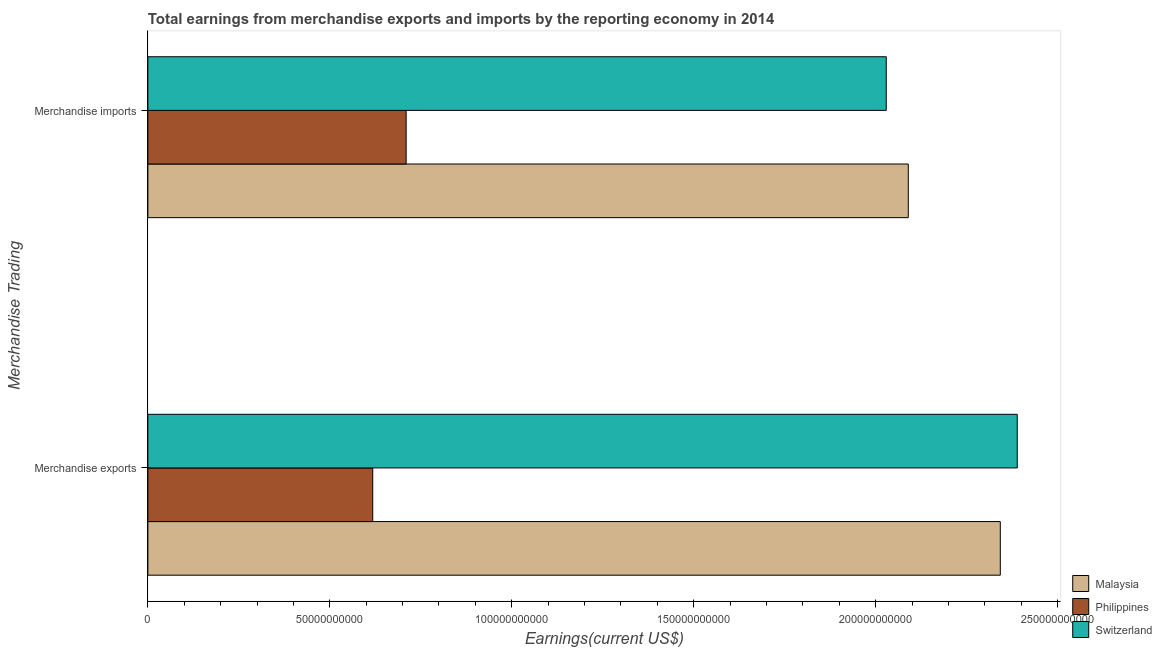How many different coloured bars are there?
Offer a very short reply. 3. Are the number of bars per tick equal to the number of legend labels?
Offer a very short reply. Yes. How many bars are there on the 2nd tick from the top?
Offer a terse response. 3. How many bars are there on the 1st tick from the bottom?
Your response must be concise. 3. What is the earnings from merchandise exports in Switzerland?
Make the answer very short. 2.39e+11. Across all countries, what is the maximum earnings from merchandise imports?
Your answer should be compact. 2.09e+11. Across all countries, what is the minimum earnings from merchandise imports?
Ensure brevity in your answer.  7.10e+1. In which country was the earnings from merchandise exports maximum?
Your answer should be very brief. Switzerland. In which country was the earnings from merchandise imports minimum?
Provide a succinct answer. Philippines. What is the total earnings from merchandise imports in the graph?
Your answer should be compact. 4.83e+11. What is the difference between the earnings from merchandise exports in Philippines and that in Switzerland?
Make the answer very short. -1.77e+11. What is the difference between the earnings from merchandise imports in Philippines and the earnings from merchandise exports in Malaysia?
Your answer should be compact. -1.63e+11. What is the average earnings from merchandise exports per country?
Offer a very short reply. 1.78e+11. What is the difference between the earnings from merchandise exports and earnings from merchandise imports in Switzerland?
Your answer should be very brief. 3.60e+1. What is the ratio of the earnings from merchandise exports in Malaysia to that in Philippines?
Ensure brevity in your answer.  3.79. In how many countries, is the earnings from merchandise imports greater than the average earnings from merchandise imports taken over all countries?
Offer a terse response. 2. What does the 3rd bar from the top in Merchandise exports represents?
Make the answer very short. Malaysia. What does the 1st bar from the bottom in Merchandise exports represents?
Offer a terse response. Malaysia. How many bars are there?
Offer a very short reply. 6. How many countries are there in the graph?
Offer a terse response. 3. Does the graph contain any zero values?
Offer a very short reply. No. Where does the legend appear in the graph?
Keep it short and to the point. Bottom right. How many legend labels are there?
Keep it short and to the point. 3. What is the title of the graph?
Offer a very short reply. Total earnings from merchandise exports and imports by the reporting economy in 2014. What is the label or title of the X-axis?
Make the answer very short. Earnings(current US$). What is the label or title of the Y-axis?
Ensure brevity in your answer.  Merchandise Trading. What is the Earnings(current US$) of Malaysia in Merchandise exports?
Provide a short and direct response. 2.34e+11. What is the Earnings(current US$) of Philippines in Merchandise exports?
Offer a very short reply. 6.18e+1. What is the Earnings(current US$) of Switzerland in Merchandise exports?
Your answer should be very brief. 2.39e+11. What is the Earnings(current US$) in Malaysia in Merchandise imports?
Give a very brief answer. 2.09e+11. What is the Earnings(current US$) in Philippines in Merchandise imports?
Your answer should be very brief. 7.10e+1. What is the Earnings(current US$) in Switzerland in Merchandise imports?
Give a very brief answer. 2.03e+11. Across all Merchandise Trading, what is the maximum Earnings(current US$) in Malaysia?
Provide a succinct answer. 2.34e+11. Across all Merchandise Trading, what is the maximum Earnings(current US$) in Philippines?
Your response must be concise. 7.10e+1. Across all Merchandise Trading, what is the maximum Earnings(current US$) of Switzerland?
Your answer should be very brief. 2.39e+11. Across all Merchandise Trading, what is the minimum Earnings(current US$) of Malaysia?
Your answer should be very brief. 2.09e+11. Across all Merchandise Trading, what is the minimum Earnings(current US$) of Philippines?
Keep it short and to the point. 6.18e+1. Across all Merchandise Trading, what is the minimum Earnings(current US$) in Switzerland?
Ensure brevity in your answer.  2.03e+11. What is the total Earnings(current US$) of Malaysia in the graph?
Your answer should be compact. 4.43e+11. What is the total Earnings(current US$) in Philippines in the graph?
Keep it short and to the point. 1.33e+11. What is the total Earnings(current US$) of Switzerland in the graph?
Your response must be concise. 4.42e+11. What is the difference between the Earnings(current US$) in Malaysia in Merchandise exports and that in Merchandise imports?
Your answer should be compact. 2.53e+1. What is the difference between the Earnings(current US$) of Philippines in Merchandise exports and that in Merchandise imports?
Ensure brevity in your answer.  -9.18e+09. What is the difference between the Earnings(current US$) in Switzerland in Merchandise exports and that in Merchandise imports?
Your answer should be very brief. 3.60e+1. What is the difference between the Earnings(current US$) of Malaysia in Merchandise exports and the Earnings(current US$) of Philippines in Merchandise imports?
Provide a short and direct response. 1.63e+11. What is the difference between the Earnings(current US$) in Malaysia in Merchandise exports and the Earnings(current US$) in Switzerland in Merchandise imports?
Your response must be concise. 3.13e+1. What is the difference between the Earnings(current US$) in Philippines in Merchandise exports and the Earnings(current US$) in Switzerland in Merchandise imports?
Offer a very short reply. -1.41e+11. What is the average Earnings(current US$) in Malaysia per Merchandise Trading?
Ensure brevity in your answer.  2.22e+11. What is the average Earnings(current US$) of Philippines per Merchandise Trading?
Keep it short and to the point. 6.64e+1. What is the average Earnings(current US$) of Switzerland per Merchandise Trading?
Make the answer very short. 2.21e+11. What is the difference between the Earnings(current US$) in Malaysia and Earnings(current US$) in Philippines in Merchandise exports?
Offer a terse response. 1.72e+11. What is the difference between the Earnings(current US$) of Malaysia and Earnings(current US$) of Switzerland in Merchandise exports?
Your answer should be compact. -4.66e+09. What is the difference between the Earnings(current US$) of Philippines and Earnings(current US$) of Switzerland in Merchandise exports?
Give a very brief answer. -1.77e+11. What is the difference between the Earnings(current US$) in Malaysia and Earnings(current US$) in Philippines in Merchandise imports?
Offer a terse response. 1.38e+11. What is the difference between the Earnings(current US$) of Malaysia and Earnings(current US$) of Switzerland in Merchandise imports?
Provide a succinct answer. 6.05e+09. What is the difference between the Earnings(current US$) in Philippines and Earnings(current US$) in Switzerland in Merchandise imports?
Keep it short and to the point. -1.32e+11. What is the ratio of the Earnings(current US$) in Malaysia in Merchandise exports to that in Merchandise imports?
Give a very brief answer. 1.12. What is the ratio of the Earnings(current US$) in Philippines in Merchandise exports to that in Merchandise imports?
Offer a terse response. 0.87. What is the ratio of the Earnings(current US$) of Switzerland in Merchandise exports to that in Merchandise imports?
Make the answer very short. 1.18. What is the difference between the highest and the second highest Earnings(current US$) of Malaysia?
Ensure brevity in your answer.  2.53e+1. What is the difference between the highest and the second highest Earnings(current US$) of Philippines?
Keep it short and to the point. 9.18e+09. What is the difference between the highest and the second highest Earnings(current US$) in Switzerland?
Give a very brief answer. 3.60e+1. What is the difference between the highest and the lowest Earnings(current US$) of Malaysia?
Offer a very short reply. 2.53e+1. What is the difference between the highest and the lowest Earnings(current US$) in Philippines?
Offer a terse response. 9.18e+09. What is the difference between the highest and the lowest Earnings(current US$) of Switzerland?
Your answer should be very brief. 3.60e+1. 